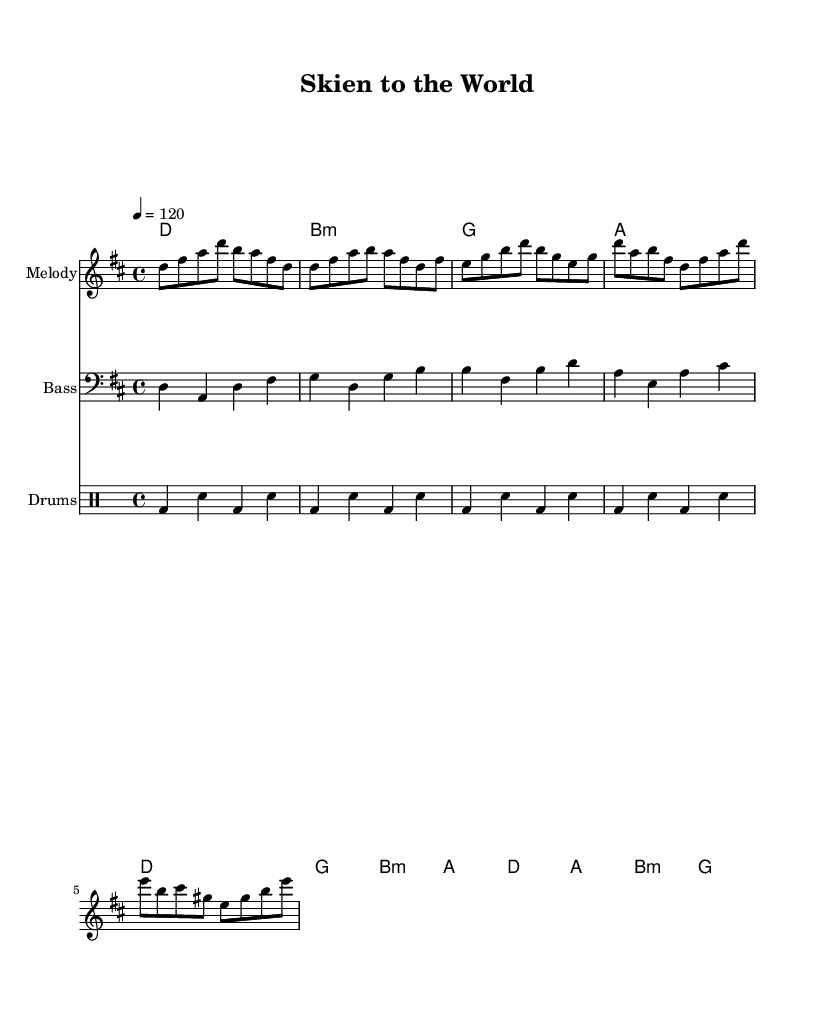What is the key signature of this music? The key signature is D major, indicated by the presence of two sharps (F# and C#) in the music.
Answer: D major What is the time signature of this music? The time signature is 4/4, shown at the beginning of the score, indicating four beats per measure with a quarter note getting one beat.
Answer: 4/4 What is the tempo marking of this music? The tempo marking is 120, specified in the score, which indicates the number of beats per minute; this means the music should be played at a moderately fast pace.
Answer: 120 How many distinct sections are present in the piece? The piece has three distinct sections: an intro, a verse, and a chorus, identifiable by their unique melodic and chord progressions.
Answer: 3 Which instrument plays the bass line? The bass line is played by a bass instrument, as indicated by the clef sign (bass clef) and the labeling of the staff.
Answer: Bass What is the name of the piece? The title of the piece is "Skien to the World," which reflects the theme of adjusting to life in a new country.
Answer: Skien to the World What is the overall mood of the piece based on its style? The piece embodies an upbeat and lively mood typical of funk music, characterized by strong rhythms and a danceable groove.
Answer: Upbeat 